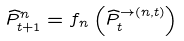Convert formula to latex. <formula><loc_0><loc_0><loc_500><loc_500>\widehat { P } _ { t + 1 } ^ { n } = f _ { n } \left ( \widehat { P } _ { t } ^ { \rightarrow ( n , t ) } \right )</formula> 